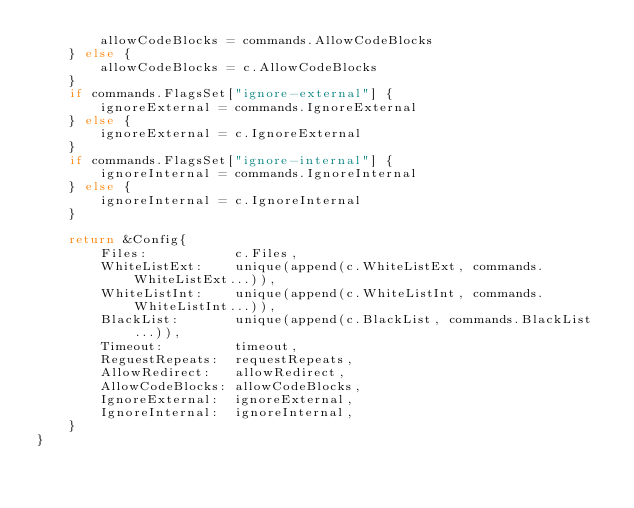Convert code to text. <code><loc_0><loc_0><loc_500><loc_500><_Go_>		allowCodeBlocks = commands.AllowCodeBlocks
	} else {
		allowCodeBlocks = c.AllowCodeBlocks
	}
	if commands.FlagsSet["ignore-external"] {
		ignoreExternal = commands.IgnoreExternal
	} else {
		ignoreExternal = c.IgnoreExternal
	}
	if commands.FlagsSet["ignore-internal"] {
		ignoreInternal = commands.IgnoreInternal
	} else {
		ignoreInternal = c.IgnoreInternal
	}

	return &Config{
		Files:           c.Files,
		WhiteListExt:    unique(append(c.WhiteListExt, commands.WhiteListExt...)),
		WhiteListInt:    unique(append(c.WhiteListInt, commands.WhiteListInt...)),
		BlackList:       unique(append(c.BlackList, commands.BlackList...)),
		Timeout:         timeout,
		ReguestRepeats:  requestRepeats,
		AllowRedirect:   allowRedirect,
		AllowCodeBlocks: allowCodeBlocks,
		IgnoreExternal:  ignoreExternal,
		IgnoreInternal:  ignoreInternal,
	}
}
</code> 